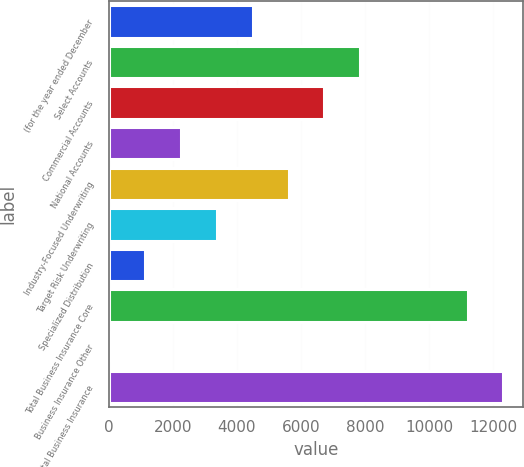Convert chart. <chart><loc_0><loc_0><loc_500><loc_500><bar_chart><fcel>(for the year ended December<fcel>Select Accounts<fcel>Commercial Accounts<fcel>National Accounts<fcel>Industry-Focused Underwriting<fcel>Target Risk Underwriting<fcel>Specialized Distribution<fcel>Total Business Insurance Core<fcel>Business Insurance Other<fcel>Total Business Insurance<nl><fcel>4497.6<fcel>7858.8<fcel>6738.4<fcel>2256.8<fcel>5618<fcel>3377.2<fcel>1136.4<fcel>11204<fcel>16<fcel>12324.4<nl></chart> 